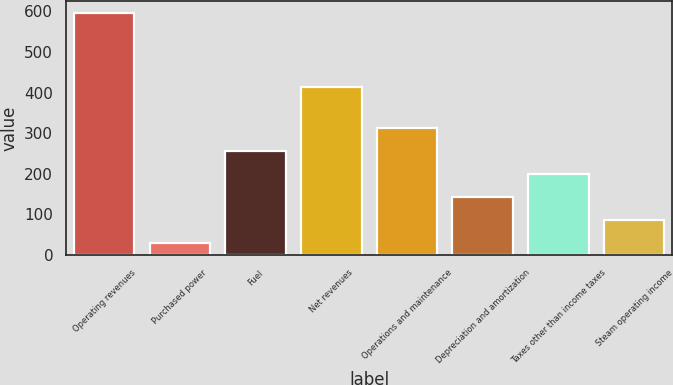Convert chart to OTSL. <chart><loc_0><loc_0><loc_500><loc_500><bar_chart><fcel>Operating revenues<fcel>Purchased power<fcel>Fuel<fcel>Net revenues<fcel>Operations and maintenance<fcel>Depreciation and amortization<fcel>Taxes other than income taxes<fcel>Steam operating income<nl><fcel>596<fcel>30<fcel>256.4<fcel>415<fcel>313<fcel>143.2<fcel>199.8<fcel>86.6<nl></chart> 